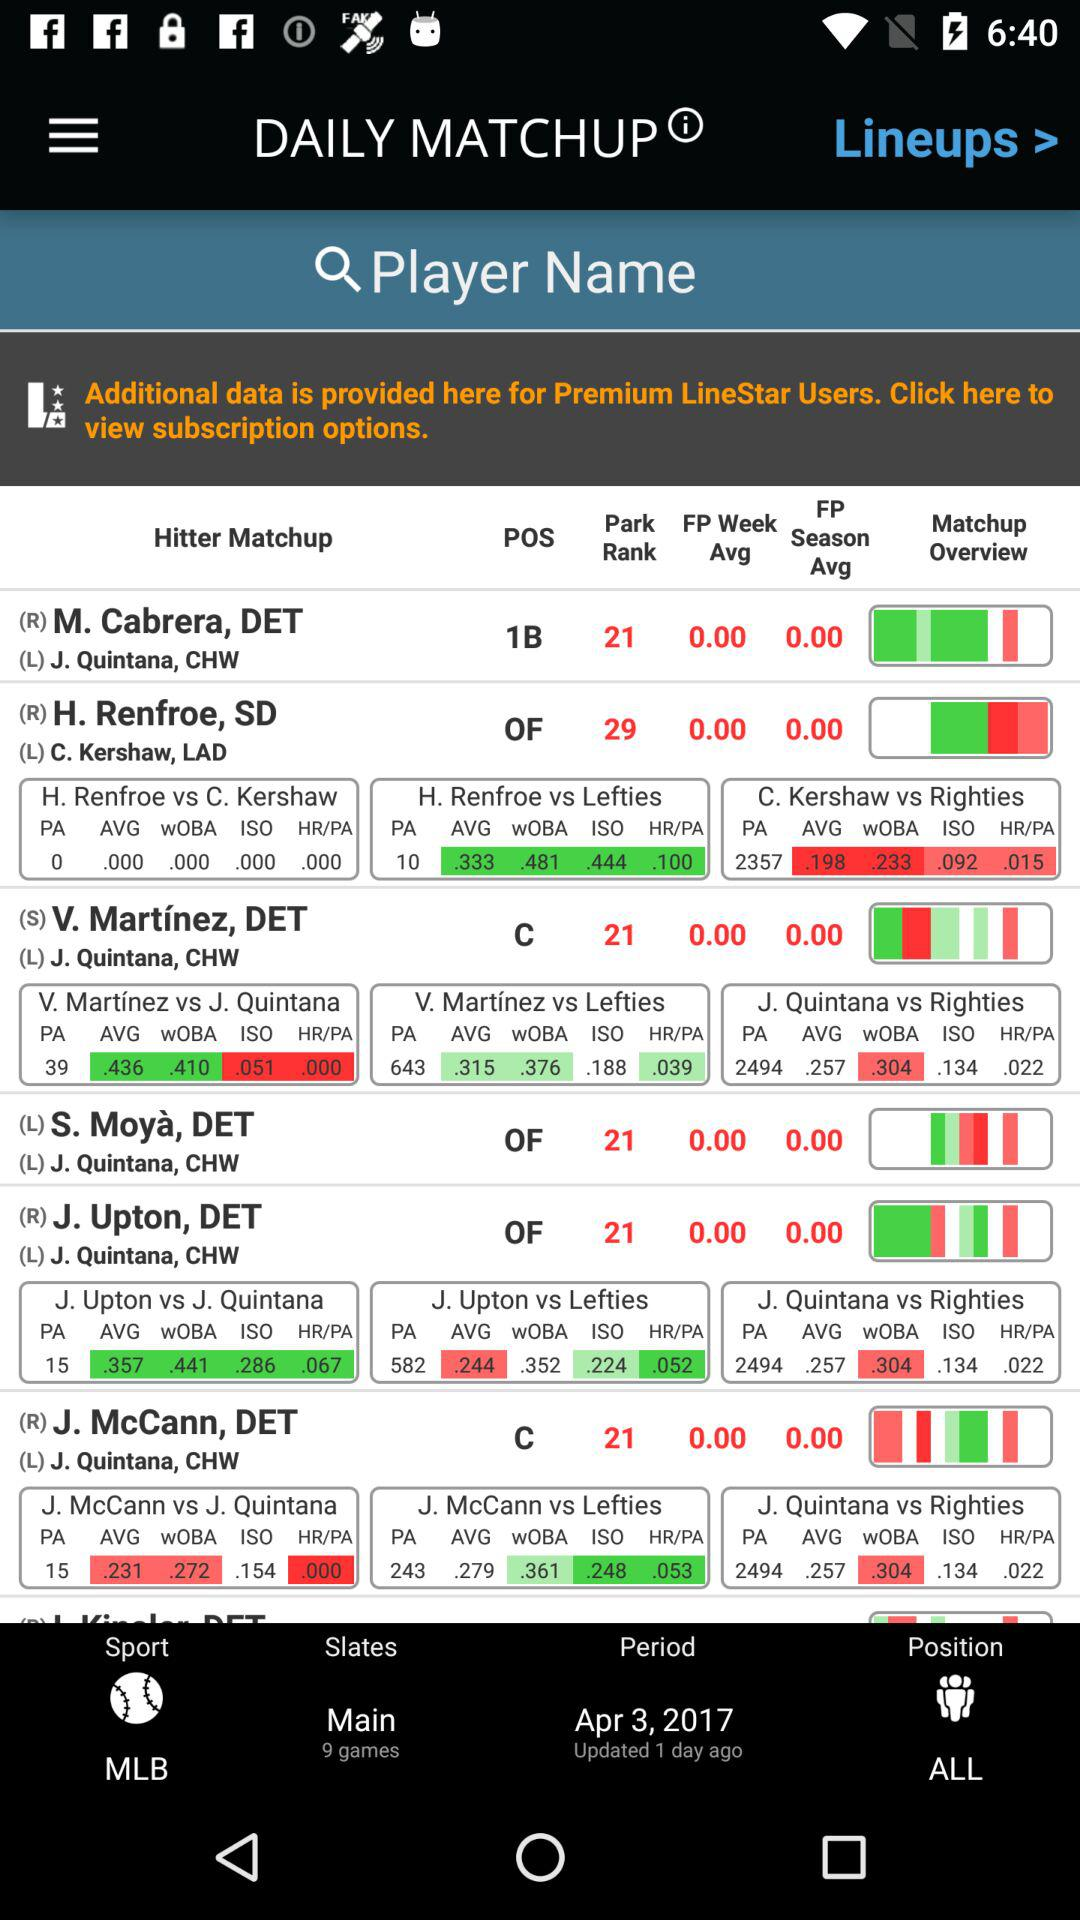What is the name of the selected league? The name of the selected league is MLB. 